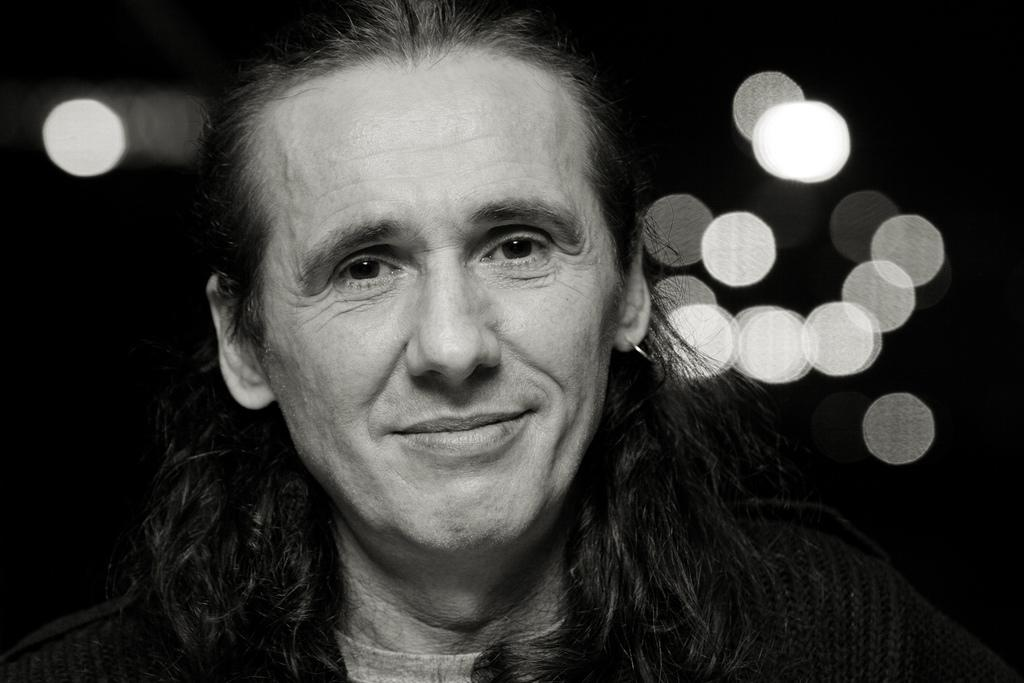What is the color scheme of the image? The image is in black and white. Who or what is the main subject in the image? There is a man in the center of the image. What can be seen in the background of the image? There are lights visible in the background of the image. What type of food is being prepared on the yam in the image? There is no food or yam present in the image; it features a man and lights in a black and white setting. 